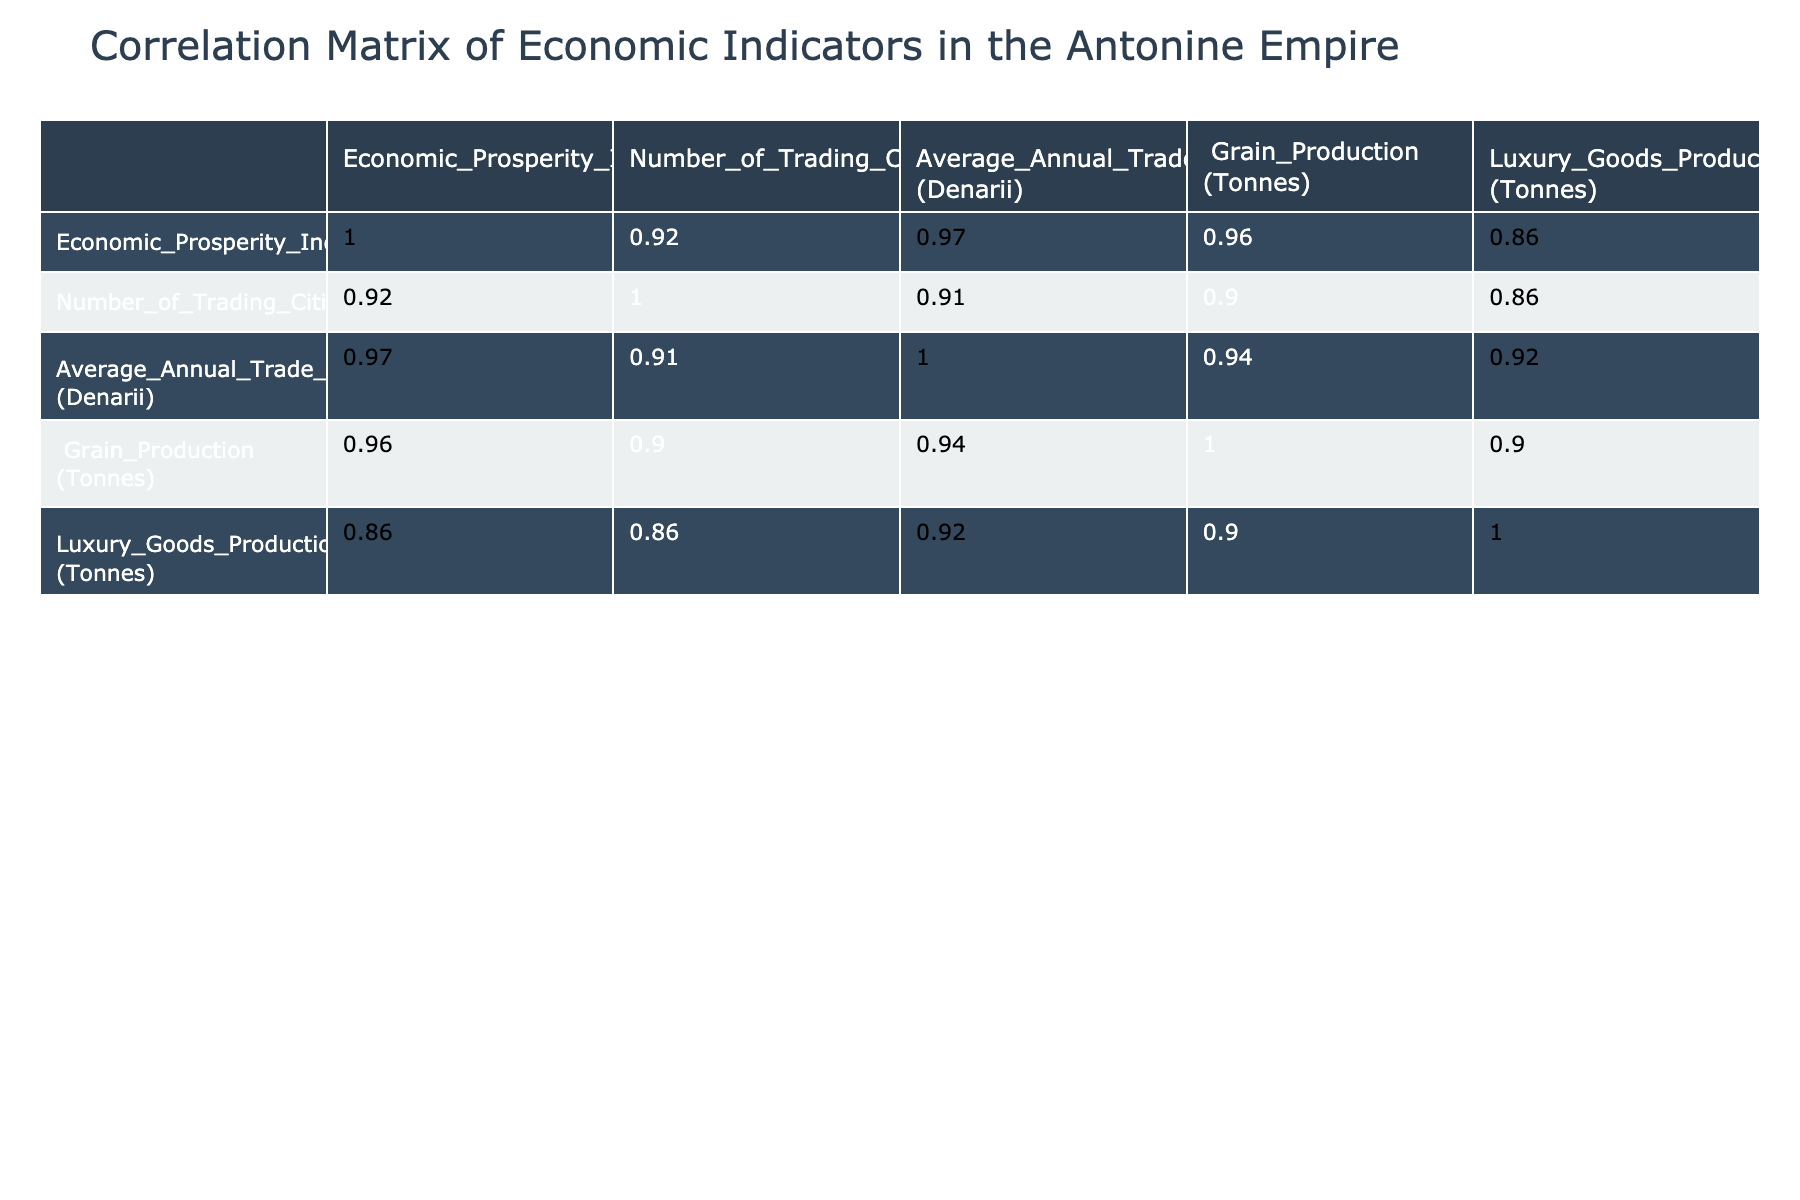What is the Economic Prosperity Index for the Maritime Route to Alexandria? The table directly indicates that the Economic Prosperity Index for the Maritime Route to Alexandria is 95.
Answer: 95 Which trade route has the highest number of trading cities? By comparing the 'Number of Trading Cities' column, the Maritime Route to Alexandria has the highest value at 15.
Answer: 15 What is the relationship between Average Annual Trade Volume and Economic Prosperity Index? To find the relationship, we note that higher Average Annual Trade Volumes generally correspond with higher Economic Prosperity Index scores, as seen with both the Maritime Route to Alexandria and the Silk Road.
Answer: Positive correlation Is the average grain production of all trade routes more than 10,000 tonnes? First, we sum the grain production: 10000 + 9000 + 11000 + 12000 + 8000 + 11500 + 13000 + 5000 = 100500. Then, divide by the number of routes (8): 100500 / 8 = 12562.5 tonnes, which is indeed more than 10,000 tonnes.
Answer: Yes What is the average Economic Prosperity Index of the trade routes with less than 10 trading cities? The routes with less than 10 trading cities are Via Aurelia (72), Suburban Routes (67), and Via Flaminia (78). Their average is (72 + 67 + 78) / 3 = 217 / 3 = 72.33.
Answer: 72.33 Which trade route produces the most luxury goods? From the 'Luxury Goods Production' column, the Silk Road produces the highest amount at 3000 tonnes.
Answer: 3000 Are all trade routes contributing to grain production equal to or above 8000 tonnes? Looking at the grain production data, Suburban Routes produce 5000 tonnes, which is below 8000. Therefore, not all trade routes meet this criterion.
Answer: No What is the combined Average Annual Trade Volume of the top three trade routes by Economic Prosperity Index? The top three routes are Maritime Route to Alexandria (75000), Silk Road (70000), and Via Egnatia (60000). Their combined volume is 75000 + 70000 + 60000 = 205000 Denarii.
Answer: 205000 